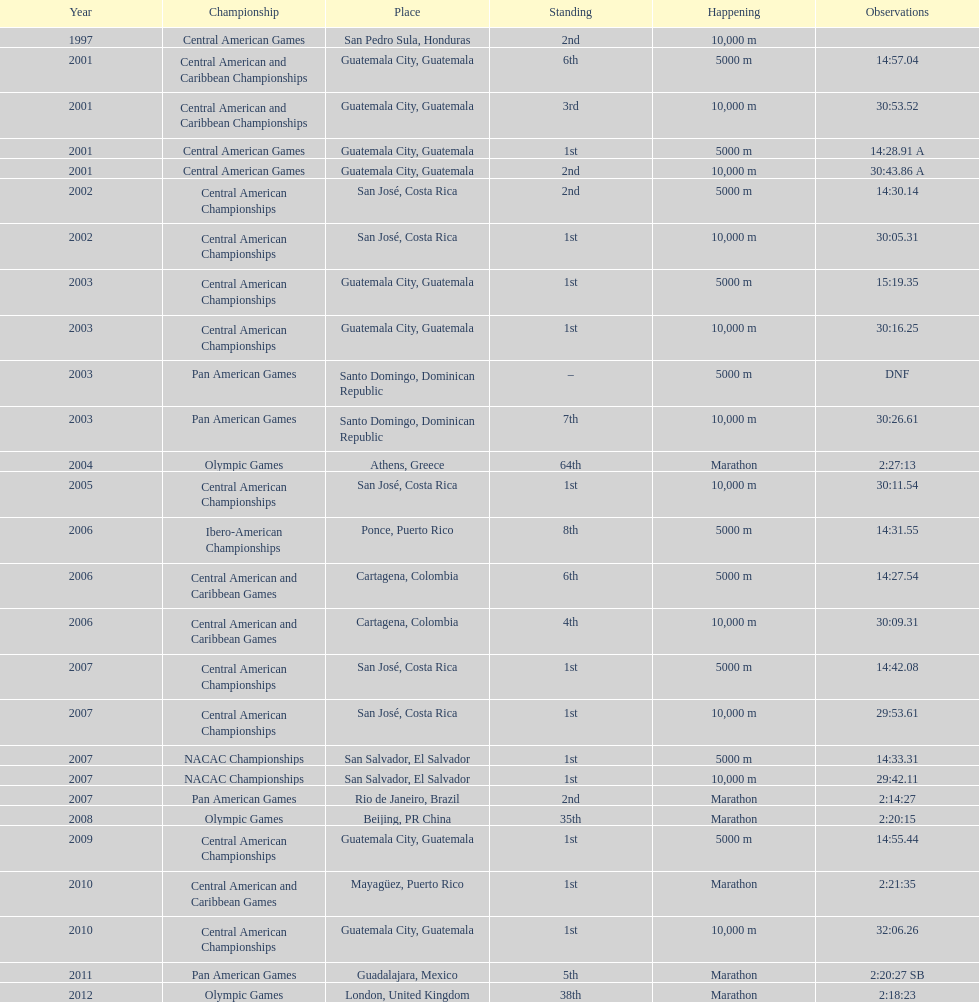How many times has the position of 1st been achieved? 12. 